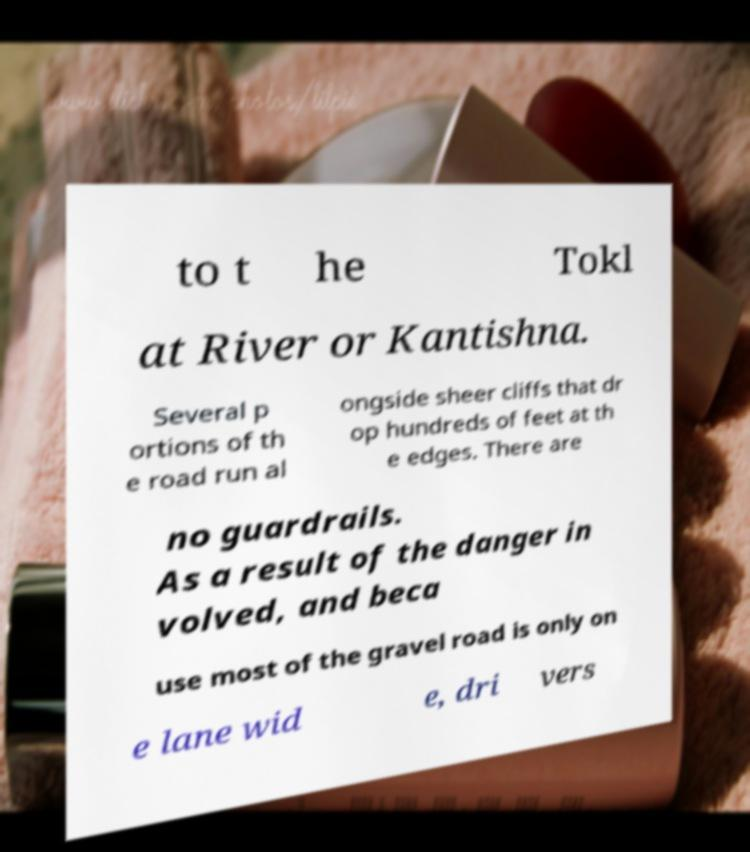Could you assist in decoding the text presented in this image and type it out clearly? to t he Tokl at River or Kantishna. Several p ortions of th e road run al ongside sheer cliffs that dr op hundreds of feet at th e edges. There are no guardrails. As a result of the danger in volved, and beca use most of the gravel road is only on e lane wid e, dri vers 